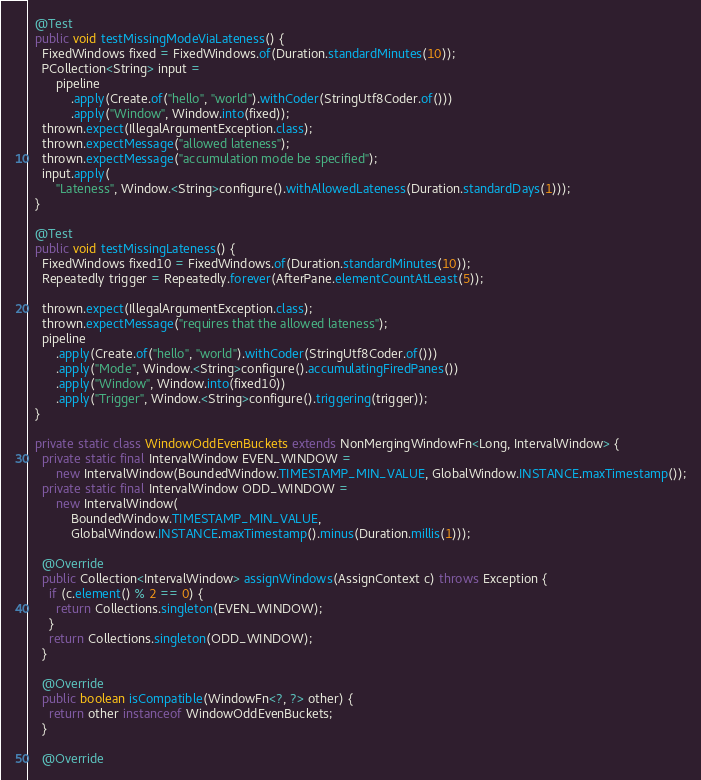<code> <loc_0><loc_0><loc_500><loc_500><_Java_>  @Test
  public void testMissingModeViaLateness() {
    FixedWindows fixed = FixedWindows.of(Duration.standardMinutes(10));
    PCollection<String> input =
        pipeline
            .apply(Create.of("hello", "world").withCoder(StringUtf8Coder.of()))
            .apply("Window", Window.into(fixed));
    thrown.expect(IllegalArgumentException.class);
    thrown.expectMessage("allowed lateness");
    thrown.expectMessage("accumulation mode be specified");
    input.apply(
        "Lateness", Window.<String>configure().withAllowedLateness(Duration.standardDays(1)));
  }

  @Test
  public void testMissingLateness() {
    FixedWindows fixed10 = FixedWindows.of(Duration.standardMinutes(10));
    Repeatedly trigger = Repeatedly.forever(AfterPane.elementCountAtLeast(5));

    thrown.expect(IllegalArgumentException.class);
    thrown.expectMessage("requires that the allowed lateness");
    pipeline
        .apply(Create.of("hello", "world").withCoder(StringUtf8Coder.of()))
        .apply("Mode", Window.<String>configure().accumulatingFiredPanes())
        .apply("Window", Window.into(fixed10))
        .apply("Trigger", Window.<String>configure().triggering(trigger));
  }

  private static class WindowOddEvenBuckets extends NonMergingWindowFn<Long, IntervalWindow> {
    private static final IntervalWindow EVEN_WINDOW =
        new IntervalWindow(BoundedWindow.TIMESTAMP_MIN_VALUE, GlobalWindow.INSTANCE.maxTimestamp());
    private static final IntervalWindow ODD_WINDOW =
        new IntervalWindow(
            BoundedWindow.TIMESTAMP_MIN_VALUE,
            GlobalWindow.INSTANCE.maxTimestamp().minus(Duration.millis(1)));

    @Override
    public Collection<IntervalWindow> assignWindows(AssignContext c) throws Exception {
      if (c.element() % 2 == 0) {
        return Collections.singleton(EVEN_WINDOW);
      }
      return Collections.singleton(ODD_WINDOW);
    }

    @Override
    public boolean isCompatible(WindowFn<?, ?> other) {
      return other instanceof WindowOddEvenBuckets;
    }

    @Override</code> 